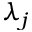<formula> <loc_0><loc_0><loc_500><loc_500>\lambda _ { j }</formula> 